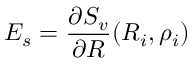<formula> <loc_0><loc_0><loc_500><loc_500>E _ { s } = \frac { \partial S _ { v } } { \partial R } ( R _ { i } , \rho _ { i } )</formula> 